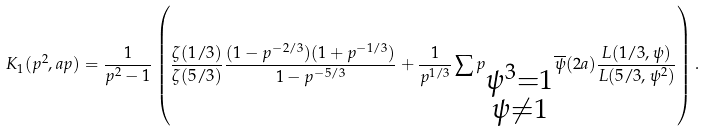<formula> <loc_0><loc_0><loc_500><loc_500>K _ { 1 } ( p ^ { 2 } , a p ) = \frac { 1 } { p ^ { 2 } - 1 } \left ( \frac { \zeta ( 1 / 3 ) } { \zeta ( 5 / 3 ) } \frac { ( 1 - p ^ { - 2 / 3 } ) ( 1 + p ^ { - 1 / 3 } ) } { 1 - p ^ { - 5 / 3 } } + \frac { 1 } { p ^ { 1 / 3 } } \sum p _ { \substack { \psi ^ { 3 } = 1 \\ \psi \neq 1 } } \overline { \psi } ( 2 a ) \frac { L ( 1 / 3 , \psi ) } { L ( 5 / 3 , \psi ^ { 2 } ) } \right ) .</formula> 